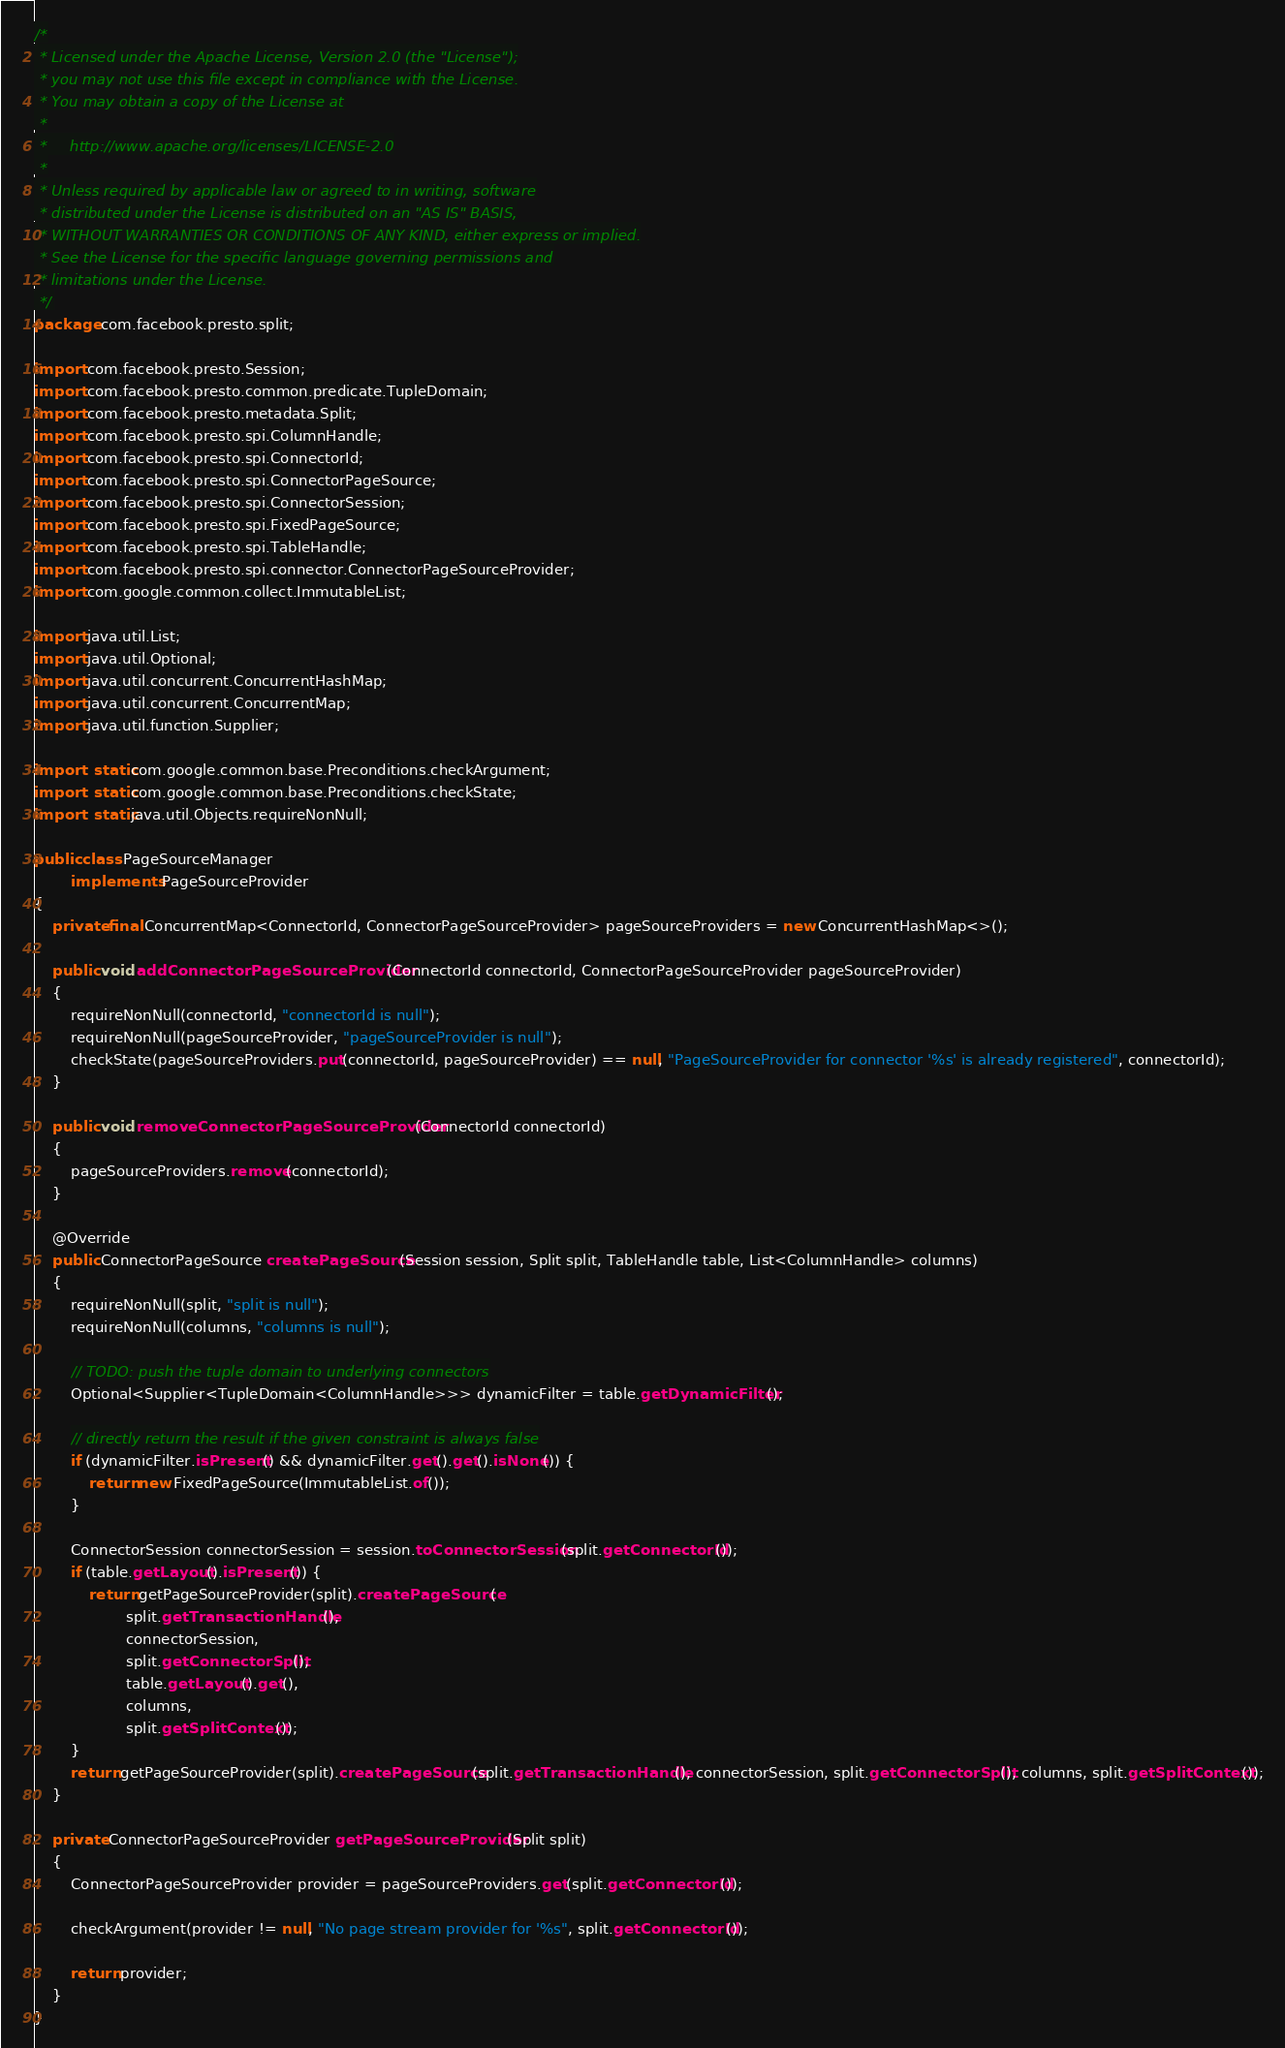Convert code to text. <code><loc_0><loc_0><loc_500><loc_500><_Java_>/*
 * Licensed under the Apache License, Version 2.0 (the "License");
 * you may not use this file except in compliance with the License.
 * You may obtain a copy of the License at
 *
 *     http://www.apache.org/licenses/LICENSE-2.0
 *
 * Unless required by applicable law or agreed to in writing, software
 * distributed under the License is distributed on an "AS IS" BASIS,
 * WITHOUT WARRANTIES OR CONDITIONS OF ANY KIND, either express or implied.
 * See the License for the specific language governing permissions and
 * limitations under the License.
 */
package com.facebook.presto.split;

import com.facebook.presto.Session;
import com.facebook.presto.common.predicate.TupleDomain;
import com.facebook.presto.metadata.Split;
import com.facebook.presto.spi.ColumnHandle;
import com.facebook.presto.spi.ConnectorId;
import com.facebook.presto.spi.ConnectorPageSource;
import com.facebook.presto.spi.ConnectorSession;
import com.facebook.presto.spi.FixedPageSource;
import com.facebook.presto.spi.TableHandle;
import com.facebook.presto.spi.connector.ConnectorPageSourceProvider;
import com.google.common.collect.ImmutableList;

import java.util.List;
import java.util.Optional;
import java.util.concurrent.ConcurrentHashMap;
import java.util.concurrent.ConcurrentMap;
import java.util.function.Supplier;

import static com.google.common.base.Preconditions.checkArgument;
import static com.google.common.base.Preconditions.checkState;
import static java.util.Objects.requireNonNull;

public class PageSourceManager
        implements PageSourceProvider
{
    private final ConcurrentMap<ConnectorId, ConnectorPageSourceProvider> pageSourceProviders = new ConcurrentHashMap<>();

    public void addConnectorPageSourceProvider(ConnectorId connectorId, ConnectorPageSourceProvider pageSourceProvider)
    {
        requireNonNull(connectorId, "connectorId is null");
        requireNonNull(pageSourceProvider, "pageSourceProvider is null");
        checkState(pageSourceProviders.put(connectorId, pageSourceProvider) == null, "PageSourceProvider for connector '%s' is already registered", connectorId);
    }

    public void removeConnectorPageSourceProvider(ConnectorId connectorId)
    {
        pageSourceProviders.remove(connectorId);
    }

    @Override
    public ConnectorPageSource createPageSource(Session session, Split split, TableHandle table, List<ColumnHandle> columns)
    {
        requireNonNull(split, "split is null");
        requireNonNull(columns, "columns is null");

        // TODO: push the tuple domain to underlying connectors
        Optional<Supplier<TupleDomain<ColumnHandle>>> dynamicFilter = table.getDynamicFilter();

        // directly return the result if the given constraint is always false
        if (dynamicFilter.isPresent() && dynamicFilter.get().get().isNone()) {
            return new FixedPageSource(ImmutableList.of());
        }

        ConnectorSession connectorSession = session.toConnectorSession(split.getConnectorId());
        if (table.getLayout().isPresent()) {
            return getPageSourceProvider(split).createPageSource(
                    split.getTransactionHandle(),
                    connectorSession,
                    split.getConnectorSplit(),
                    table.getLayout().get(),
                    columns,
                    split.getSplitContext());
        }
        return getPageSourceProvider(split).createPageSource(split.getTransactionHandle(), connectorSession, split.getConnectorSplit(), columns, split.getSplitContext());
    }

    private ConnectorPageSourceProvider getPageSourceProvider(Split split)
    {
        ConnectorPageSourceProvider provider = pageSourceProviders.get(split.getConnectorId());

        checkArgument(provider != null, "No page stream provider for '%s", split.getConnectorId());

        return provider;
    }
}
</code> 